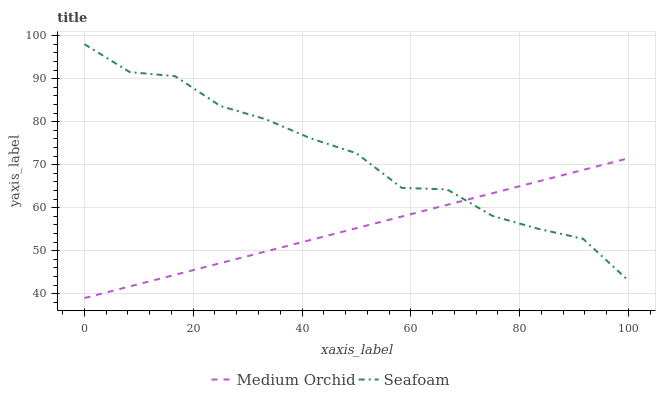Does Medium Orchid have the minimum area under the curve?
Answer yes or no. Yes. Does Seafoam have the maximum area under the curve?
Answer yes or no. Yes. Does Seafoam have the minimum area under the curve?
Answer yes or no. No. Is Medium Orchid the smoothest?
Answer yes or no. Yes. Is Seafoam the roughest?
Answer yes or no. Yes. Is Seafoam the smoothest?
Answer yes or no. No. Does Medium Orchid have the lowest value?
Answer yes or no. Yes. Does Seafoam have the lowest value?
Answer yes or no. No. Does Seafoam have the highest value?
Answer yes or no. Yes. Does Seafoam intersect Medium Orchid?
Answer yes or no. Yes. Is Seafoam less than Medium Orchid?
Answer yes or no. No. Is Seafoam greater than Medium Orchid?
Answer yes or no. No. 